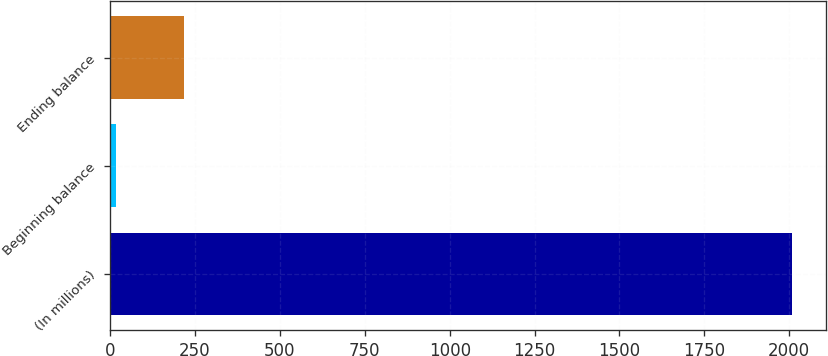Convert chart to OTSL. <chart><loc_0><loc_0><loc_500><loc_500><bar_chart><fcel>(In millions)<fcel>Beginning balance<fcel>Ending balance<nl><fcel>2009<fcel>18<fcel>217.1<nl></chart> 